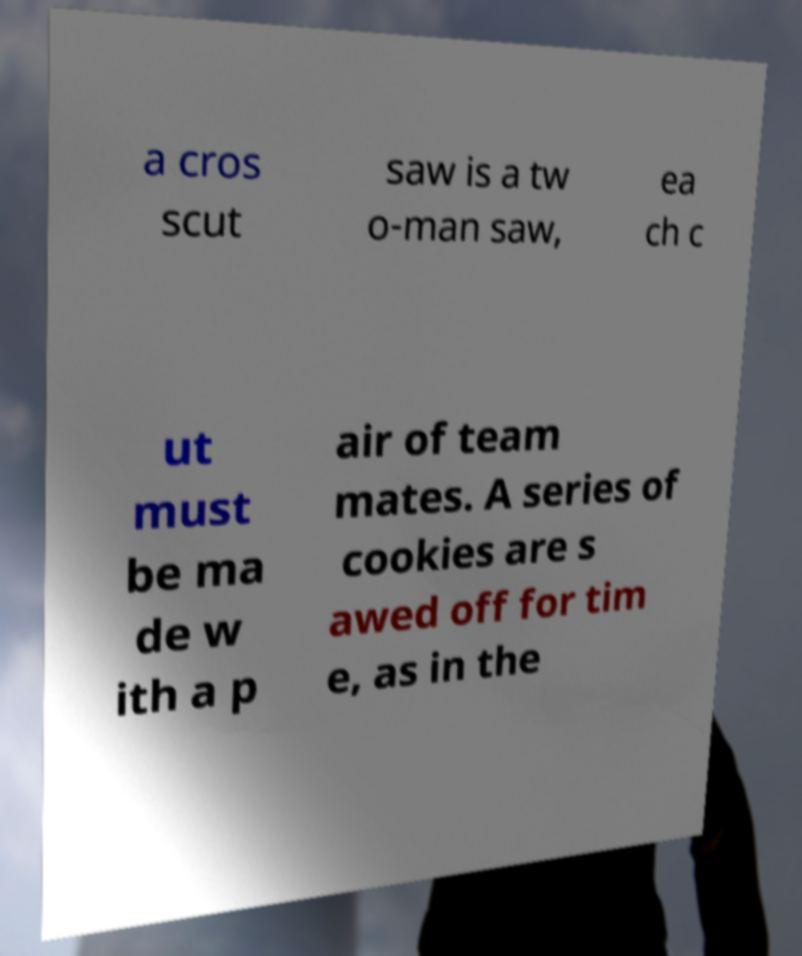There's text embedded in this image that I need extracted. Can you transcribe it verbatim? a cros scut saw is a tw o-man saw, ea ch c ut must be ma de w ith a p air of team mates. A series of cookies are s awed off for tim e, as in the 